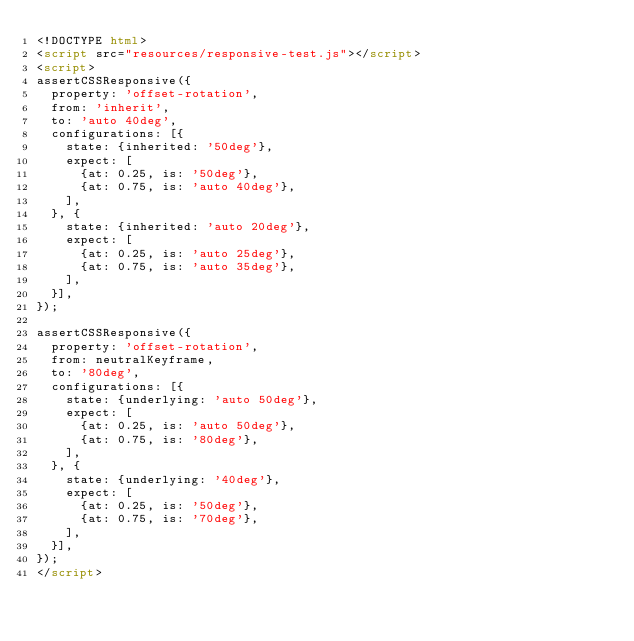<code> <loc_0><loc_0><loc_500><loc_500><_HTML_><!DOCTYPE html>
<script src="resources/responsive-test.js"></script>
<script>
assertCSSResponsive({
  property: 'offset-rotation',
  from: 'inherit',
  to: 'auto 40deg',
  configurations: [{
    state: {inherited: '50deg'},
    expect: [
      {at: 0.25, is: '50deg'},
      {at: 0.75, is: 'auto 40deg'},
    ],
  }, {
    state: {inherited: 'auto 20deg'},
    expect: [
      {at: 0.25, is: 'auto 25deg'},
      {at: 0.75, is: 'auto 35deg'},
    ],
  }],
});

assertCSSResponsive({
  property: 'offset-rotation',
  from: neutralKeyframe,
  to: '80deg',
  configurations: [{
    state: {underlying: 'auto 50deg'},
    expect: [
      {at: 0.25, is: 'auto 50deg'},
      {at: 0.75, is: '80deg'},
    ],
  }, {
    state: {underlying: '40deg'},
    expect: [
      {at: 0.25, is: '50deg'},
      {at: 0.75, is: '70deg'},
    ],
  }],
});
</script>
</code> 